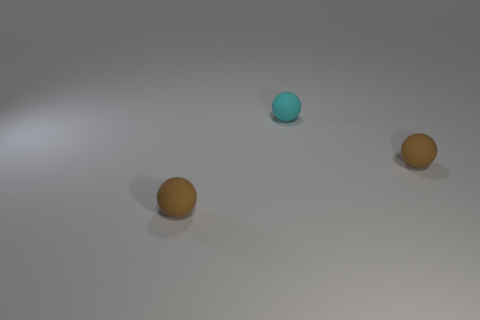Add 2 small cyan matte spheres. How many objects exist? 5 Add 3 tiny brown balls. How many tiny brown balls are left? 5 Add 1 brown balls. How many brown balls exist? 3 Subtract 0 yellow blocks. How many objects are left? 3 Subtract all small objects. Subtract all small brown matte blocks. How many objects are left? 0 